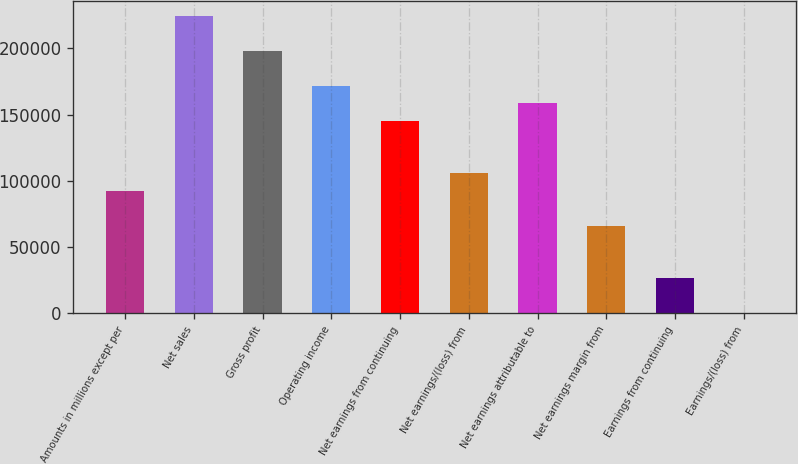Convert chart to OTSL. <chart><loc_0><loc_0><loc_500><loc_500><bar_chart><fcel>Amounts in millions except per<fcel>Net sales<fcel>Gross profit<fcel>Operating income<fcel>Net earnings from continuing<fcel>Net earnings/(loss) from<fcel>Net earnings attributable to<fcel>Net earnings margin from<fcel>Earnings from continuing<fcel>Earnings/(loss) from<nl><fcel>92571.1<fcel>224814<fcel>198366<fcel>171917<fcel>145468<fcel>105795<fcel>158693<fcel>66122.4<fcel>26449.4<fcel>0.74<nl></chart> 